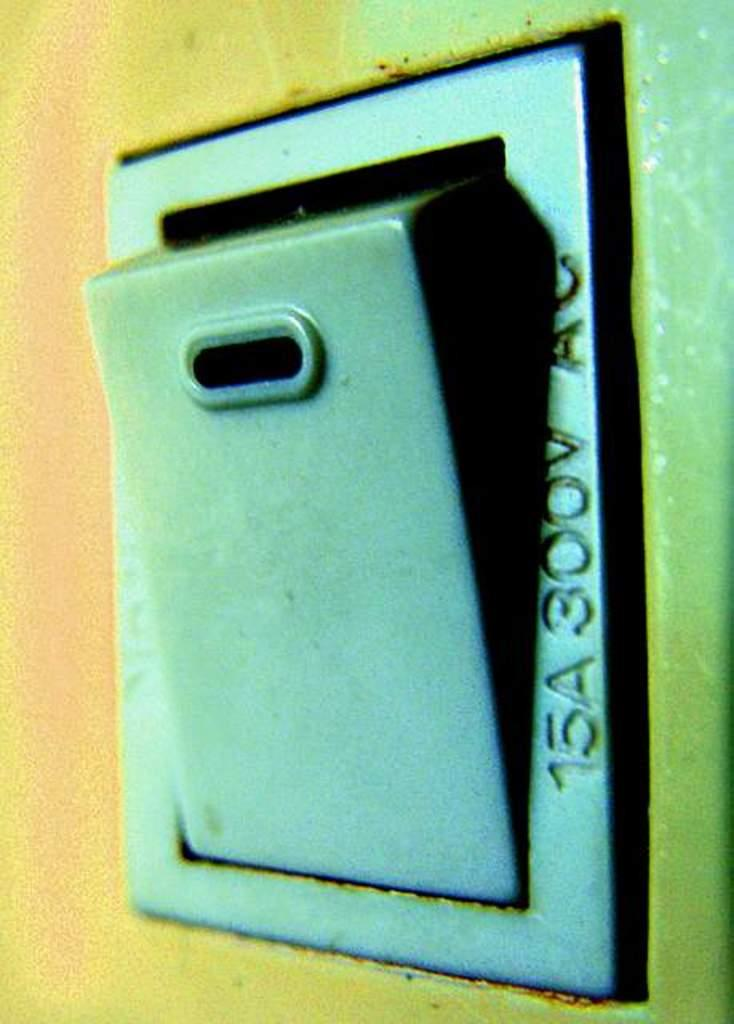<image>
Describe the image concisely. An outlet box with 15A 300V AC on the side. 